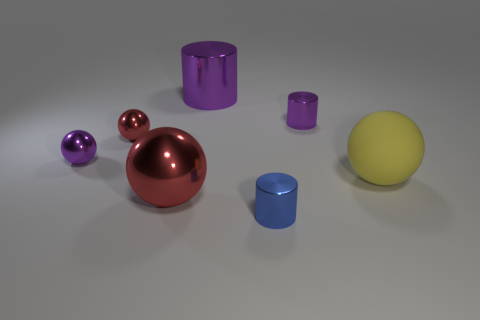What is the size of the shiny object that is the same color as the large metal ball?
Make the answer very short. Small. Do the tiny purple thing that is on the left side of the tiny blue shiny thing and the big metallic thing that is behind the yellow object have the same shape?
Offer a very short reply. No. What material is the object that is the same color as the big shiny sphere?
Your response must be concise. Metal. Is there a large yellow rubber object?
Ensure brevity in your answer.  Yes. There is a large thing that is the same shape as the small blue object; what material is it?
Your response must be concise. Metal. Are there any blue shiny objects behind the large yellow sphere?
Your response must be concise. No. Do the large object that is in front of the yellow matte ball and the tiny purple cylinder have the same material?
Your answer should be very brief. Yes. Is there a tiny shiny ball that has the same color as the rubber ball?
Your answer should be very brief. No. There is a yellow rubber object; what shape is it?
Make the answer very short. Sphere. The small object that is in front of the small metallic sphere that is in front of the tiny red object is what color?
Make the answer very short. Blue. 